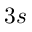Convert formula to latex. <formula><loc_0><loc_0><loc_500><loc_500>3 s</formula> 